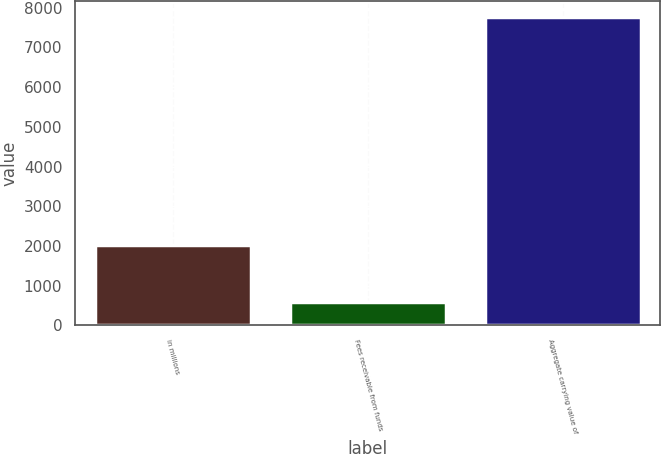<chart> <loc_0><loc_0><loc_500><loc_500><bar_chart><fcel>in millions<fcel>Fees receivable from funds<fcel>Aggregate carrying value of<nl><fcel>2015<fcel>599<fcel>7768<nl></chart> 